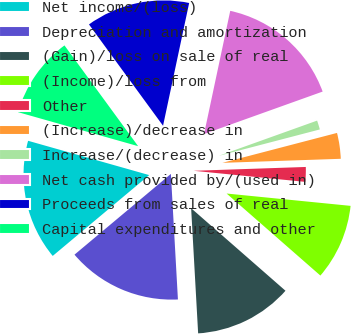Convert chart. <chart><loc_0><loc_0><loc_500><loc_500><pie_chart><fcel>Net income/(loss)<fcel>Depreciation and amortization<fcel>(Gain)/loss on sale of real<fcel>(Income)/loss from<fcel>Other<fcel>(Increase)/decrease in<fcel>Increase/(decrease) in<fcel>Net cash provided by/(used in)<fcel>Proceeds from sales of real<fcel>Capital expenditures and other<nl><fcel>15.49%<fcel>14.79%<fcel>12.67%<fcel>9.86%<fcel>2.12%<fcel>3.52%<fcel>1.41%<fcel>16.19%<fcel>13.38%<fcel>10.56%<nl></chart> 